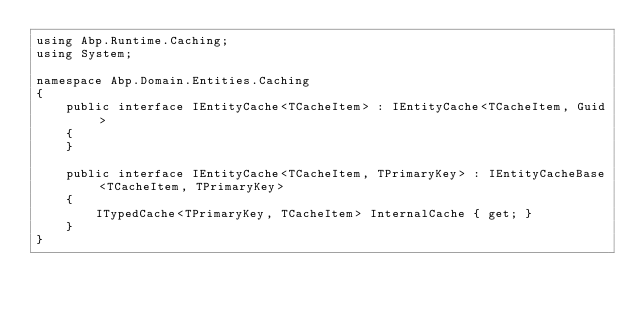Convert code to text. <code><loc_0><loc_0><loc_500><loc_500><_C#_>using Abp.Runtime.Caching;
using System;

namespace Abp.Domain.Entities.Caching
{
    public interface IEntityCache<TCacheItem> : IEntityCache<TCacheItem, Guid>
    {
    }

    public interface IEntityCache<TCacheItem, TPrimaryKey> : IEntityCacheBase<TCacheItem, TPrimaryKey>
    {
        ITypedCache<TPrimaryKey, TCacheItem> InternalCache { get; }
    }
}</code> 